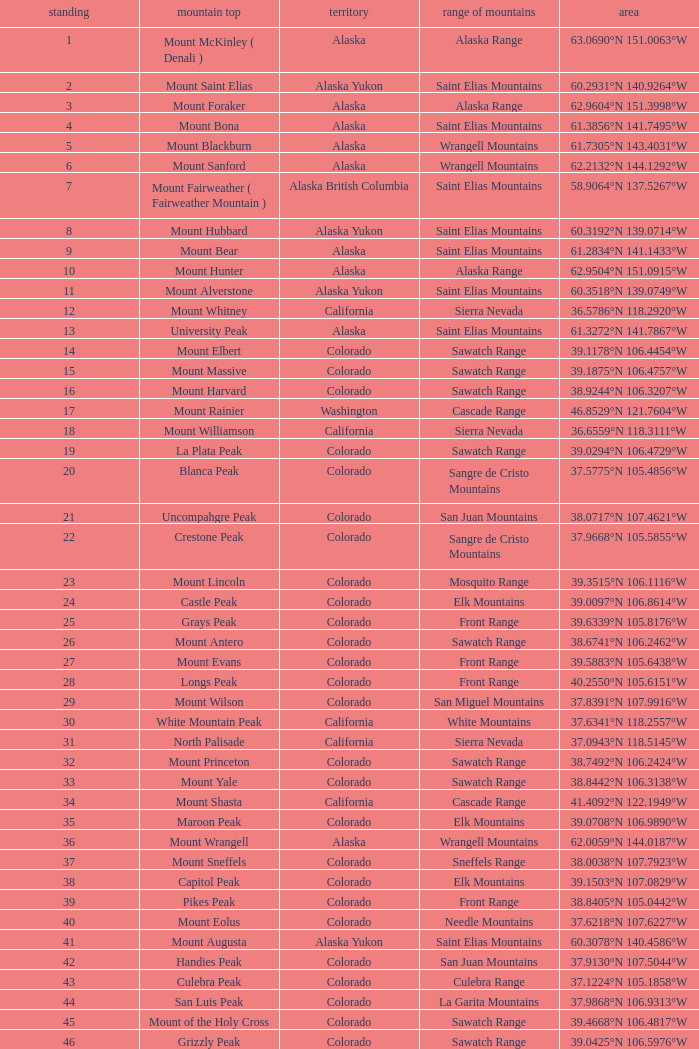What is the rank when the state is colorado and the location is 37.7859°n 107.7039°w? 83.0. 